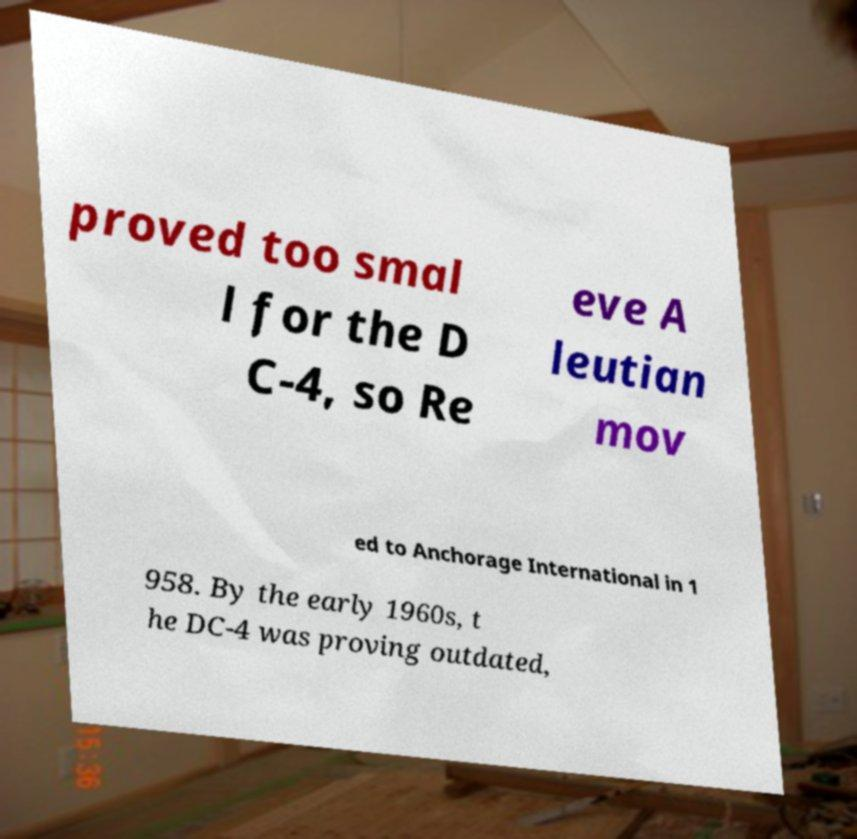Can you accurately transcribe the text from the provided image for me? proved too smal l for the D C-4, so Re eve A leutian mov ed to Anchorage International in 1 958. By the early 1960s, t he DC-4 was proving outdated, 